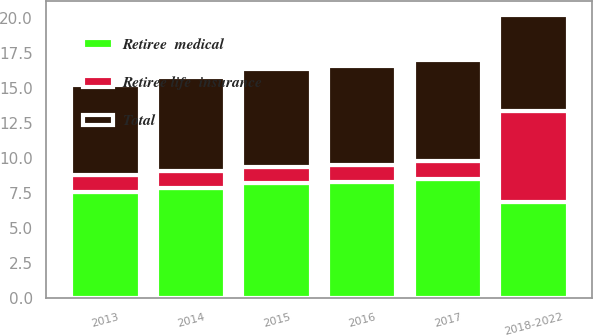Convert chart. <chart><loc_0><loc_0><loc_500><loc_500><stacked_bar_chart><ecel><fcel>2013<fcel>2014<fcel>2015<fcel>2016<fcel>2017<fcel>2018-2022<nl><fcel>Total<fcel>6.4<fcel>6.7<fcel>7<fcel>7.1<fcel>7.2<fcel>6.85<nl><fcel>Retiree life  insurance<fcel>1.2<fcel>1.2<fcel>1.2<fcel>1.2<fcel>1.3<fcel>6.5<nl><fcel>Retiree  medical<fcel>7.6<fcel>7.9<fcel>8.2<fcel>8.3<fcel>8.5<fcel>6.85<nl></chart> 